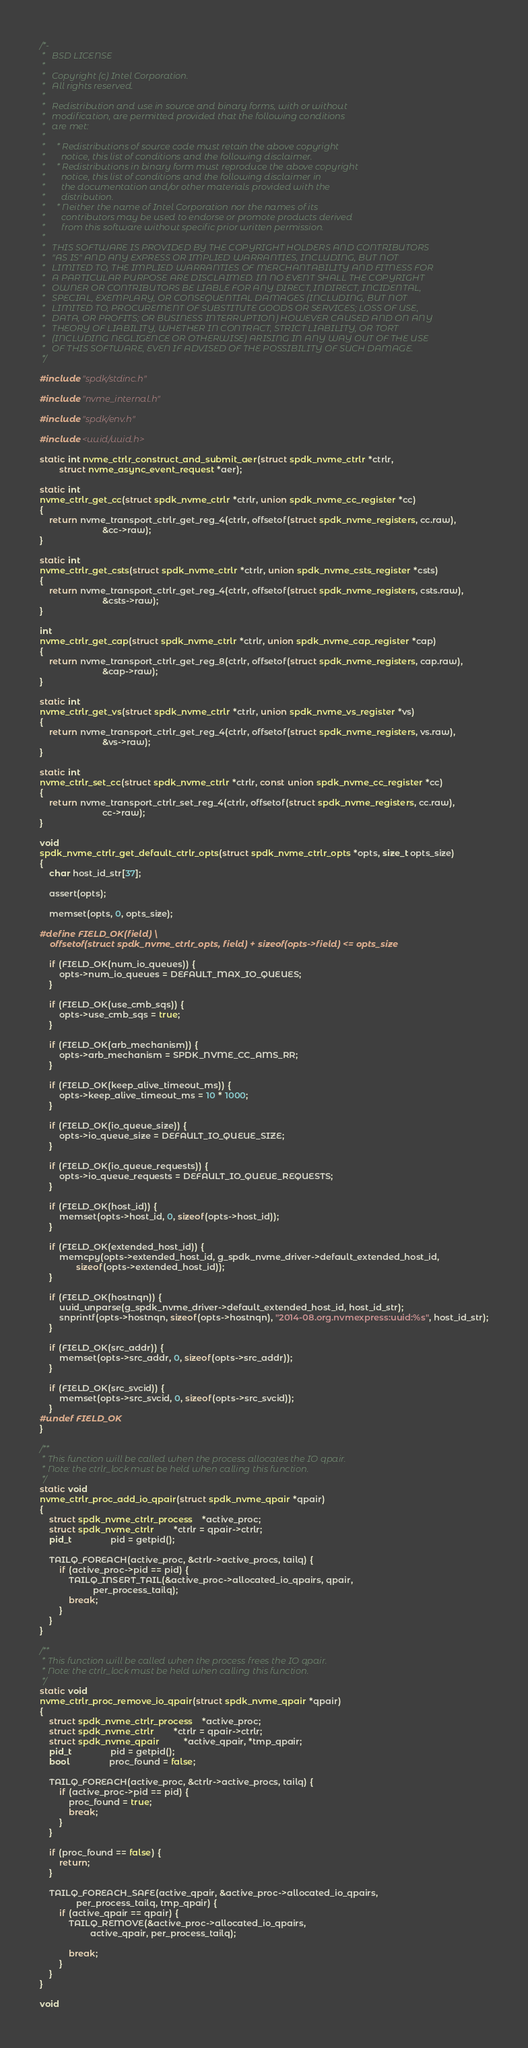<code> <loc_0><loc_0><loc_500><loc_500><_C_>/*-
 *   BSD LICENSE
 *
 *   Copyright (c) Intel Corporation.
 *   All rights reserved.
 *
 *   Redistribution and use in source and binary forms, with or without
 *   modification, are permitted provided that the following conditions
 *   are met:
 *
 *     * Redistributions of source code must retain the above copyright
 *       notice, this list of conditions and the following disclaimer.
 *     * Redistributions in binary form must reproduce the above copyright
 *       notice, this list of conditions and the following disclaimer in
 *       the documentation and/or other materials provided with the
 *       distribution.
 *     * Neither the name of Intel Corporation nor the names of its
 *       contributors may be used to endorse or promote products derived
 *       from this software without specific prior written permission.
 *
 *   THIS SOFTWARE IS PROVIDED BY THE COPYRIGHT HOLDERS AND CONTRIBUTORS
 *   "AS IS" AND ANY EXPRESS OR IMPLIED WARRANTIES, INCLUDING, BUT NOT
 *   LIMITED TO, THE IMPLIED WARRANTIES OF MERCHANTABILITY AND FITNESS FOR
 *   A PARTICULAR PURPOSE ARE DISCLAIMED. IN NO EVENT SHALL THE COPYRIGHT
 *   OWNER OR CONTRIBUTORS BE LIABLE FOR ANY DIRECT, INDIRECT, INCIDENTAL,
 *   SPECIAL, EXEMPLARY, OR CONSEQUENTIAL DAMAGES (INCLUDING, BUT NOT
 *   LIMITED TO, PROCUREMENT OF SUBSTITUTE GOODS OR SERVICES; LOSS OF USE,
 *   DATA, OR PROFITS; OR BUSINESS INTERRUPTION) HOWEVER CAUSED AND ON ANY
 *   THEORY OF LIABILITY, WHETHER IN CONTRACT, STRICT LIABILITY, OR TORT
 *   (INCLUDING NEGLIGENCE OR OTHERWISE) ARISING IN ANY WAY OUT OF THE USE
 *   OF THIS SOFTWARE, EVEN IF ADVISED OF THE POSSIBILITY OF SUCH DAMAGE.
 */

#include "spdk/stdinc.h"

#include "nvme_internal.h"

#include "spdk/env.h"

#include <uuid/uuid.h>

static int nvme_ctrlr_construct_and_submit_aer(struct spdk_nvme_ctrlr *ctrlr,
		struct nvme_async_event_request *aer);

static int
nvme_ctrlr_get_cc(struct spdk_nvme_ctrlr *ctrlr, union spdk_nvme_cc_register *cc)
{
	return nvme_transport_ctrlr_get_reg_4(ctrlr, offsetof(struct spdk_nvme_registers, cc.raw),
					      &cc->raw);
}

static int
nvme_ctrlr_get_csts(struct spdk_nvme_ctrlr *ctrlr, union spdk_nvme_csts_register *csts)
{
	return nvme_transport_ctrlr_get_reg_4(ctrlr, offsetof(struct spdk_nvme_registers, csts.raw),
					      &csts->raw);
}

int
nvme_ctrlr_get_cap(struct spdk_nvme_ctrlr *ctrlr, union spdk_nvme_cap_register *cap)
{
	return nvme_transport_ctrlr_get_reg_8(ctrlr, offsetof(struct spdk_nvme_registers, cap.raw),
					      &cap->raw);
}

static int
nvme_ctrlr_get_vs(struct spdk_nvme_ctrlr *ctrlr, union spdk_nvme_vs_register *vs)
{
	return nvme_transport_ctrlr_get_reg_4(ctrlr, offsetof(struct spdk_nvme_registers, vs.raw),
					      &vs->raw);
}

static int
nvme_ctrlr_set_cc(struct spdk_nvme_ctrlr *ctrlr, const union spdk_nvme_cc_register *cc)
{
	return nvme_transport_ctrlr_set_reg_4(ctrlr, offsetof(struct spdk_nvme_registers, cc.raw),
					      cc->raw);
}

void
spdk_nvme_ctrlr_get_default_ctrlr_opts(struct spdk_nvme_ctrlr_opts *opts, size_t opts_size)
{
	char host_id_str[37];

	assert(opts);

	memset(opts, 0, opts_size);

#define FIELD_OK(field) \
	offsetof(struct spdk_nvme_ctrlr_opts, field) + sizeof(opts->field) <= opts_size

	if (FIELD_OK(num_io_queues)) {
		opts->num_io_queues = DEFAULT_MAX_IO_QUEUES;
	}

	if (FIELD_OK(use_cmb_sqs)) {
		opts->use_cmb_sqs = true;
	}

	if (FIELD_OK(arb_mechanism)) {
		opts->arb_mechanism = SPDK_NVME_CC_AMS_RR;
	}

	if (FIELD_OK(keep_alive_timeout_ms)) {
		opts->keep_alive_timeout_ms = 10 * 1000;
	}

	if (FIELD_OK(io_queue_size)) {
		opts->io_queue_size = DEFAULT_IO_QUEUE_SIZE;
	}

	if (FIELD_OK(io_queue_requests)) {
		opts->io_queue_requests = DEFAULT_IO_QUEUE_REQUESTS;
	}

	if (FIELD_OK(host_id)) {
		memset(opts->host_id, 0, sizeof(opts->host_id));
	}

	if (FIELD_OK(extended_host_id)) {
		memcpy(opts->extended_host_id, g_spdk_nvme_driver->default_extended_host_id,
		       sizeof(opts->extended_host_id));
	}

	if (FIELD_OK(hostnqn)) {
		uuid_unparse(g_spdk_nvme_driver->default_extended_host_id, host_id_str);
		snprintf(opts->hostnqn, sizeof(opts->hostnqn), "2014-08.org.nvmexpress:uuid:%s", host_id_str);
	}

	if (FIELD_OK(src_addr)) {
		memset(opts->src_addr, 0, sizeof(opts->src_addr));
	}

	if (FIELD_OK(src_svcid)) {
		memset(opts->src_svcid, 0, sizeof(opts->src_svcid));
	}
#undef FIELD_OK
}

/**
 * This function will be called when the process allocates the IO qpair.
 * Note: the ctrlr_lock must be held when calling this function.
 */
static void
nvme_ctrlr_proc_add_io_qpair(struct spdk_nvme_qpair *qpair)
{
	struct spdk_nvme_ctrlr_process	*active_proc;
	struct spdk_nvme_ctrlr		*ctrlr = qpair->ctrlr;
	pid_t				pid = getpid();

	TAILQ_FOREACH(active_proc, &ctrlr->active_procs, tailq) {
		if (active_proc->pid == pid) {
			TAILQ_INSERT_TAIL(&active_proc->allocated_io_qpairs, qpair,
					  per_process_tailq);
			break;
		}
	}
}

/**
 * This function will be called when the process frees the IO qpair.
 * Note: the ctrlr_lock must be held when calling this function.
 */
static void
nvme_ctrlr_proc_remove_io_qpair(struct spdk_nvme_qpair *qpair)
{
	struct spdk_nvme_ctrlr_process	*active_proc;
	struct spdk_nvme_ctrlr		*ctrlr = qpair->ctrlr;
	struct spdk_nvme_qpair          *active_qpair, *tmp_qpair;
	pid_t				pid = getpid();
	bool				proc_found = false;

	TAILQ_FOREACH(active_proc, &ctrlr->active_procs, tailq) {
		if (active_proc->pid == pid) {
			proc_found = true;
			break;
		}
	}

	if (proc_found == false) {
		return;
	}

	TAILQ_FOREACH_SAFE(active_qpair, &active_proc->allocated_io_qpairs,
			   per_process_tailq, tmp_qpair) {
		if (active_qpair == qpair) {
			TAILQ_REMOVE(&active_proc->allocated_io_qpairs,
				     active_qpair, per_process_tailq);

			break;
		}
	}
}

void</code> 